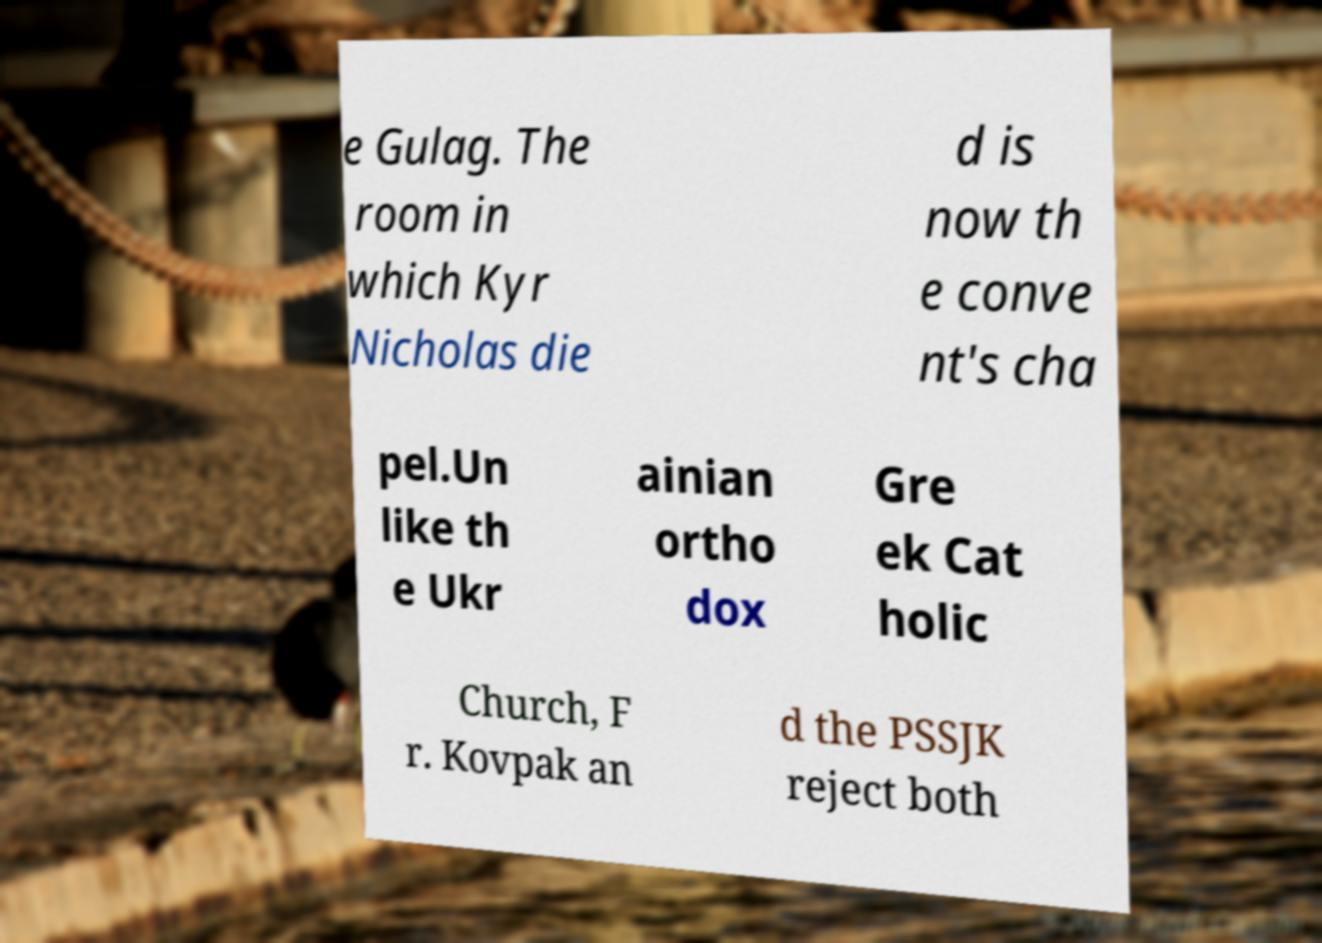Could you assist in decoding the text presented in this image and type it out clearly? e Gulag. The room in which Kyr Nicholas die d is now th e conve nt's cha pel.Un like th e Ukr ainian ortho dox Gre ek Cat holic Church, F r. Kovpak an d the PSSJK reject both 